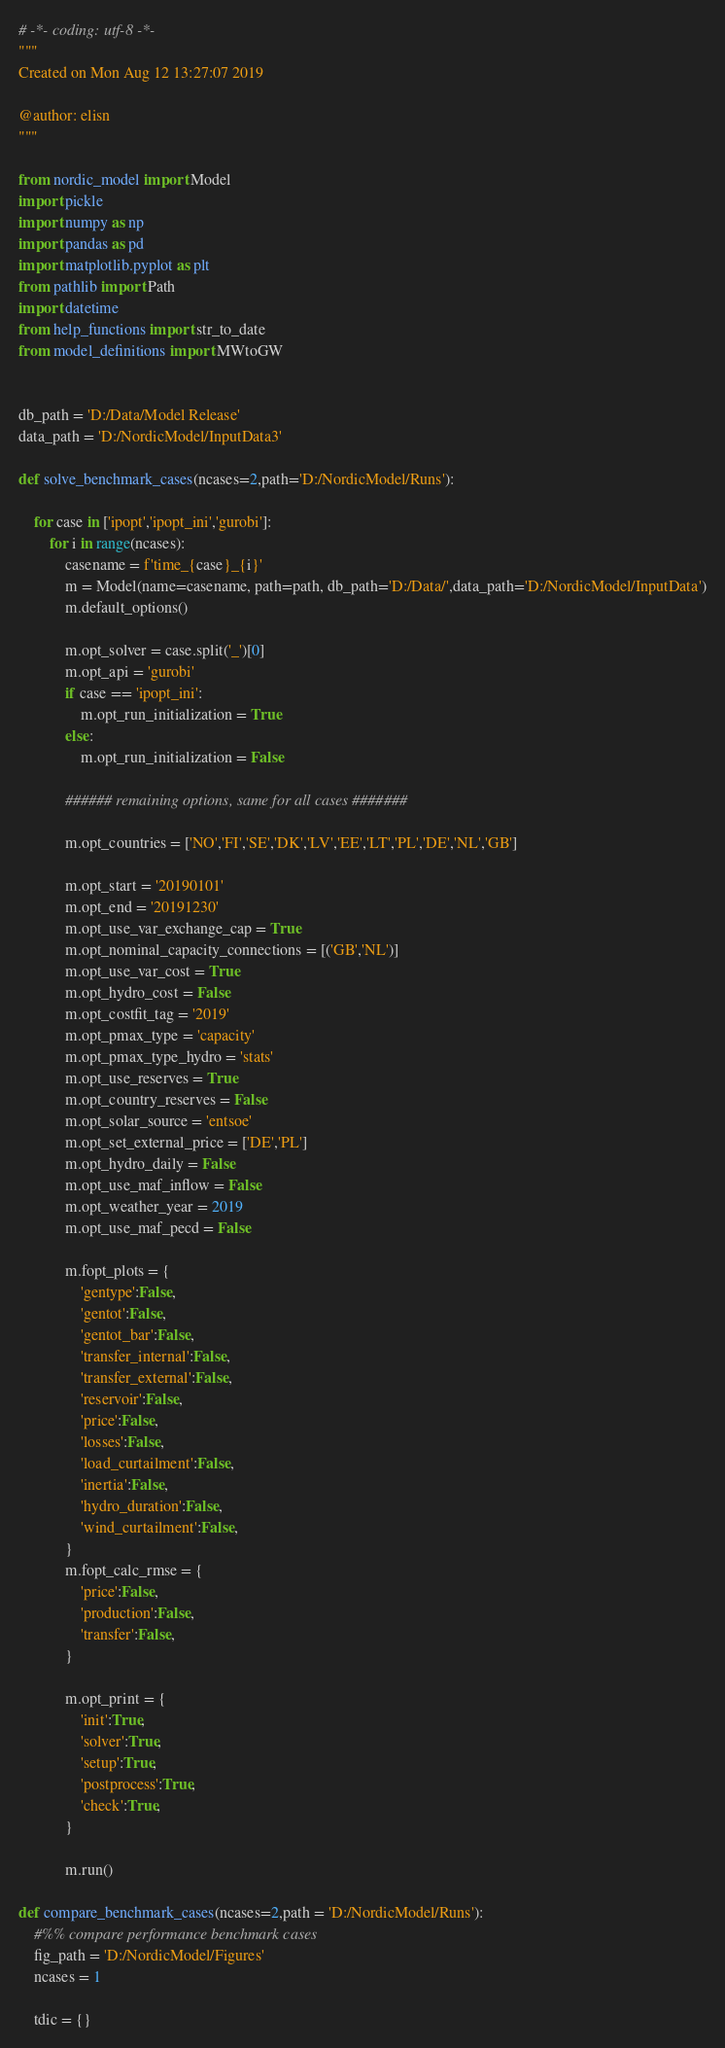<code> <loc_0><loc_0><loc_500><loc_500><_Python_># -*- coding: utf-8 -*-
"""
Created on Mon Aug 12 13:27:07 2019

@author: elisn
"""

from nordic_model import Model
import pickle
import numpy as np
import pandas as pd
import matplotlib.pyplot as plt
from pathlib import Path
import datetime
from help_functions import str_to_date
from model_definitions import MWtoGW


db_path = 'D:/Data/Model Release'
data_path = 'D:/NordicModel/InputData3'

def solve_benchmark_cases(ncases=2,path='D:/NordicModel/Runs'):

    for case in ['ipopt','ipopt_ini','gurobi']:
        for i in range(ncases):
            casename = f'time_{case}_{i}'
            m = Model(name=casename, path=path, db_path='D:/Data/',data_path='D:/NordicModel/InputData')
            m.default_options()

            m.opt_solver = case.split('_')[0]
            m.opt_api = 'gurobi'
            if case == 'ipopt_ini':
                m.opt_run_initialization = True
            else:
                m.opt_run_initialization = False

            ###### remaining options, same for all cases #######

            m.opt_countries = ['NO','FI','SE','DK','LV','EE','LT','PL','DE','NL','GB']

            m.opt_start = '20190101'
            m.opt_end = '20191230'
            m.opt_use_var_exchange_cap = True
            m.opt_nominal_capacity_connections = [('GB','NL')]
            m.opt_use_var_cost = True
            m.opt_hydro_cost = False
            m.opt_costfit_tag = '2019'
            m.opt_pmax_type = 'capacity'
            m.opt_pmax_type_hydro = 'stats'
            m.opt_use_reserves = True
            m.opt_country_reserves = False
            m.opt_solar_source = 'entsoe'
            m.opt_set_external_price = ['DE','PL']
            m.opt_hydro_daily = False
            m.opt_use_maf_inflow = False
            m.opt_weather_year = 2019
            m.opt_use_maf_pecd = False

            m.fopt_plots = {
                'gentype':False,
                'gentot':False,
                'gentot_bar':False,
                'transfer_internal':False,
                'transfer_external':False,
                'reservoir':False,
                'price':False,
                'losses':False,
                'load_curtailment':False,
                'inertia':False,
                'hydro_duration':False,
                'wind_curtailment':False,
            }
            m.fopt_calc_rmse = {
                'price':False,
                'production':False,
                'transfer':False,
            }

            m.opt_print = {
                'init':True,
                'solver':True,
                'setup':True,
                'postprocess':True,
                'check':True,
            }

            m.run()

def compare_benchmark_cases(ncases=2,path = 'D:/NordicModel/Runs'):
    #%% compare performance benchmark cases
    fig_path = 'D:/NordicModel/Figures'
    ncases = 1

    tdic = {}</code> 